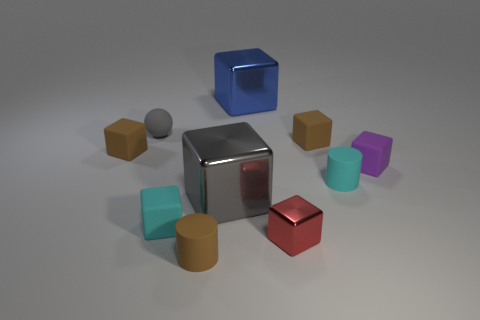How many other things are there of the same size as the red shiny thing?
Your answer should be very brief. 7. Is there anything else that is the same shape as the small red thing?
Give a very brief answer. Yes. Is the number of tiny spheres that are on the right side of the brown rubber cylinder the same as the number of matte blocks?
Provide a short and direct response. No. What number of things have the same material as the cyan cylinder?
Your answer should be very brief. 6. What is the color of the other cylinder that is the same material as the brown cylinder?
Offer a very short reply. Cyan. Do the big blue object and the small purple rubber object have the same shape?
Make the answer very short. Yes. There is a tiny rubber cylinder behind the small rubber cube that is in front of the purple matte object; are there any small gray objects right of it?
Offer a terse response. No. How many other tiny balls are the same color as the sphere?
Your answer should be compact. 0. The cyan object that is the same size as the cyan rubber cube is what shape?
Keep it short and to the point. Cylinder. Are there any small cyan rubber cylinders in front of the large gray shiny thing?
Ensure brevity in your answer.  No. 